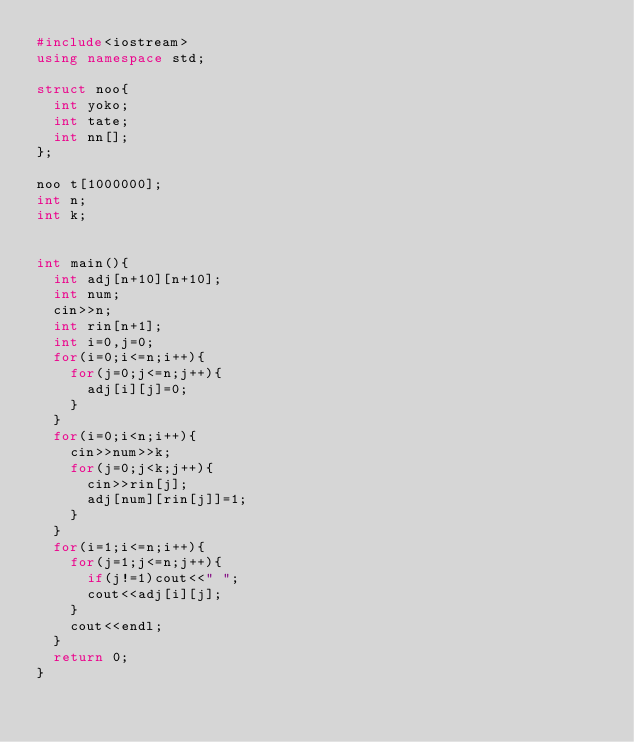<code> <loc_0><loc_0><loc_500><loc_500><_C++_>#include<iostream>
using namespace std;

struct noo{
  int yoko;
  int tate;
  int nn[];
};

noo t[1000000];
int n;
int k;


int main(){
  int adj[n+10][n+10];
  int num;
  cin>>n;
  int rin[n+1];
  int i=0,j=0;
  for(i=0;i<=n;i++){
    for(j=0;j<=n;j++){
      adj[i][j]=0;
    }
  }
  for(i=0;i<n;i++){
    cin>>num>>k;
    for(j=0;j<k;j++){
      cin>>rin[j];
      adj[num][rin[j]]=1;
    }
  }
  for(i=1;i<=n;i++){
    for(j=1;j<=n;j++){
      if(j!=1)cout<<" ";
      cout<<adj[i][j];
    }
    cout<<endl;
  }
  return 0;
}

</code> 